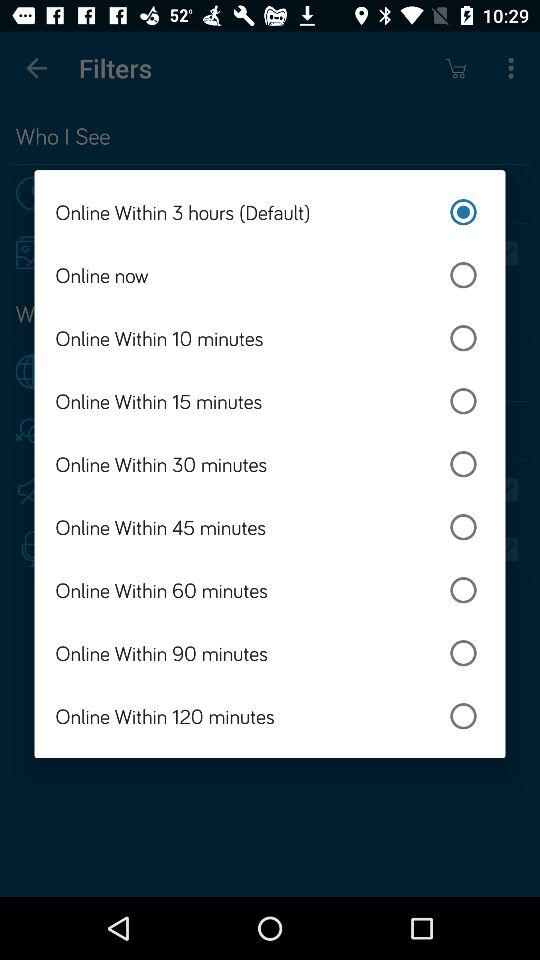What is the selected option? The selected option is "Online Within 3 hours (Default)". 